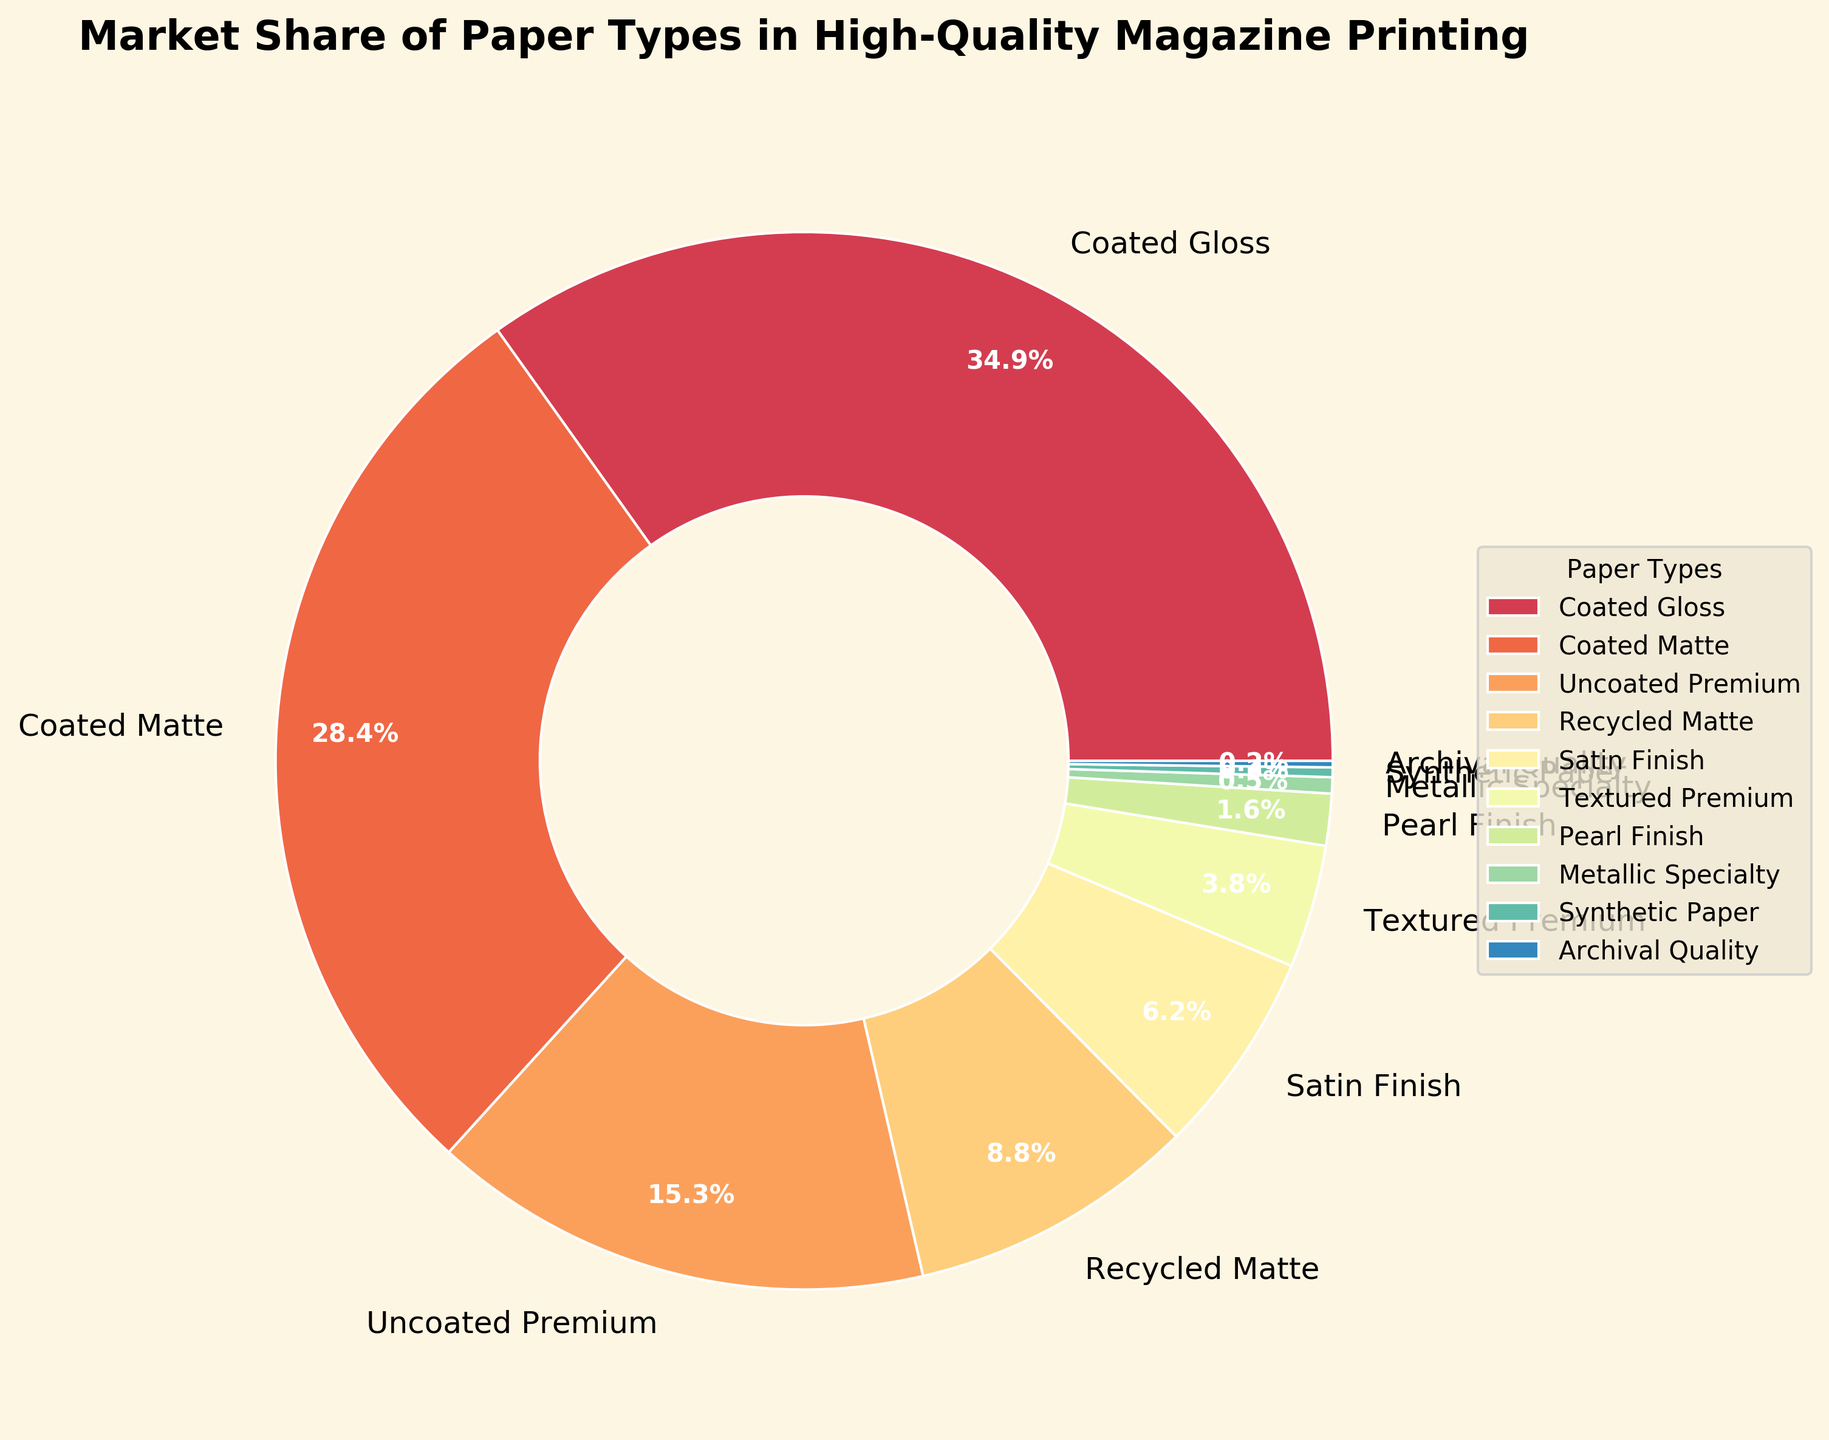Which paper type has the largest market share? The figure shows various paper types with their market share percentages, and the one with the highest percentage value represents the largest market share. Coated Gloss has the largest segment with 35.2% market share.
Answer: Coated Gloss How much more market share does Coated Gloss have compared to Coated Matte? Coated Gloss has a market share of 35.2%, and Coated Matte has 28.7%. Subtract the market share of Coated Matte from Coated Gloss: 35.2% - 28.7% = 6.5%.
Answer: 6.5% What is the combined market share of the three least common paper types? The three least common paper types are Archival Quality (0.2%), Synthetic Paper (0.3%), and Metallic Specialty (0.5%). Adding these together gives: 0.2% + 0.3% + 0.5% = 1%.
Answer: 1% What is the visual attribute (color) associated with Textured Premium? The pie chart uses distinct colors for each paper type. Textured Premium is represented by a unique color segment which is visually identifiable.
Answer: The specific color can be seen on the pie chart Which segments occupy more than a quarter of the market individually? In the pie chart, segments that occupy more than 25% of the market will be larger than one quarter of the pie. Coated Gloss (35.2%) and Coated Matte (28.7%) are the segments larger than 25%.
Answer: Coated Gloss and Coated Matte What is the average market share percentage of Uncoated Premium, Recycled Matte, and Satin Finish? Uncoated Premium has 15.5%, Recycled Matte has 8.9%, and Satin Finish has 6.3%. To calculate the average: (15.5 + 8.9 + 6.3) / 3 = 10.23%.
Answer: 10.23% Which paper type has nearly the same market share as Recycled Matte? Recycled Matte has a market share of 8.9%. The closest value to this is Satin Finish with 6.3%, but it is not nearly the same. None of the paper types have nearly the same market share as Recycled Matte.
Answer: None What is the total market share of paper types that are below 5%? The paper types below 5% are Textured Premium (3.8%), Pearl Finish (1.6%), Metallic Specialty (0.5%), Synthetic Paper (0.3%), and Archival Quality (0.2%). Adding these gives: 3.8% + 1.6% + 0.5% + 0.3% + 0.2% = 6.4%.
Answer: 6.4% Between which two adjacent slices in the pie chart is the largest visible gap? Examining the pie chart, the gap between Coated Matte (28.7%) and Uncoated Premium (15.5%) is the most noticeable due to their percentages.
Answer: Between Coated Matte and Uncoated Premium 